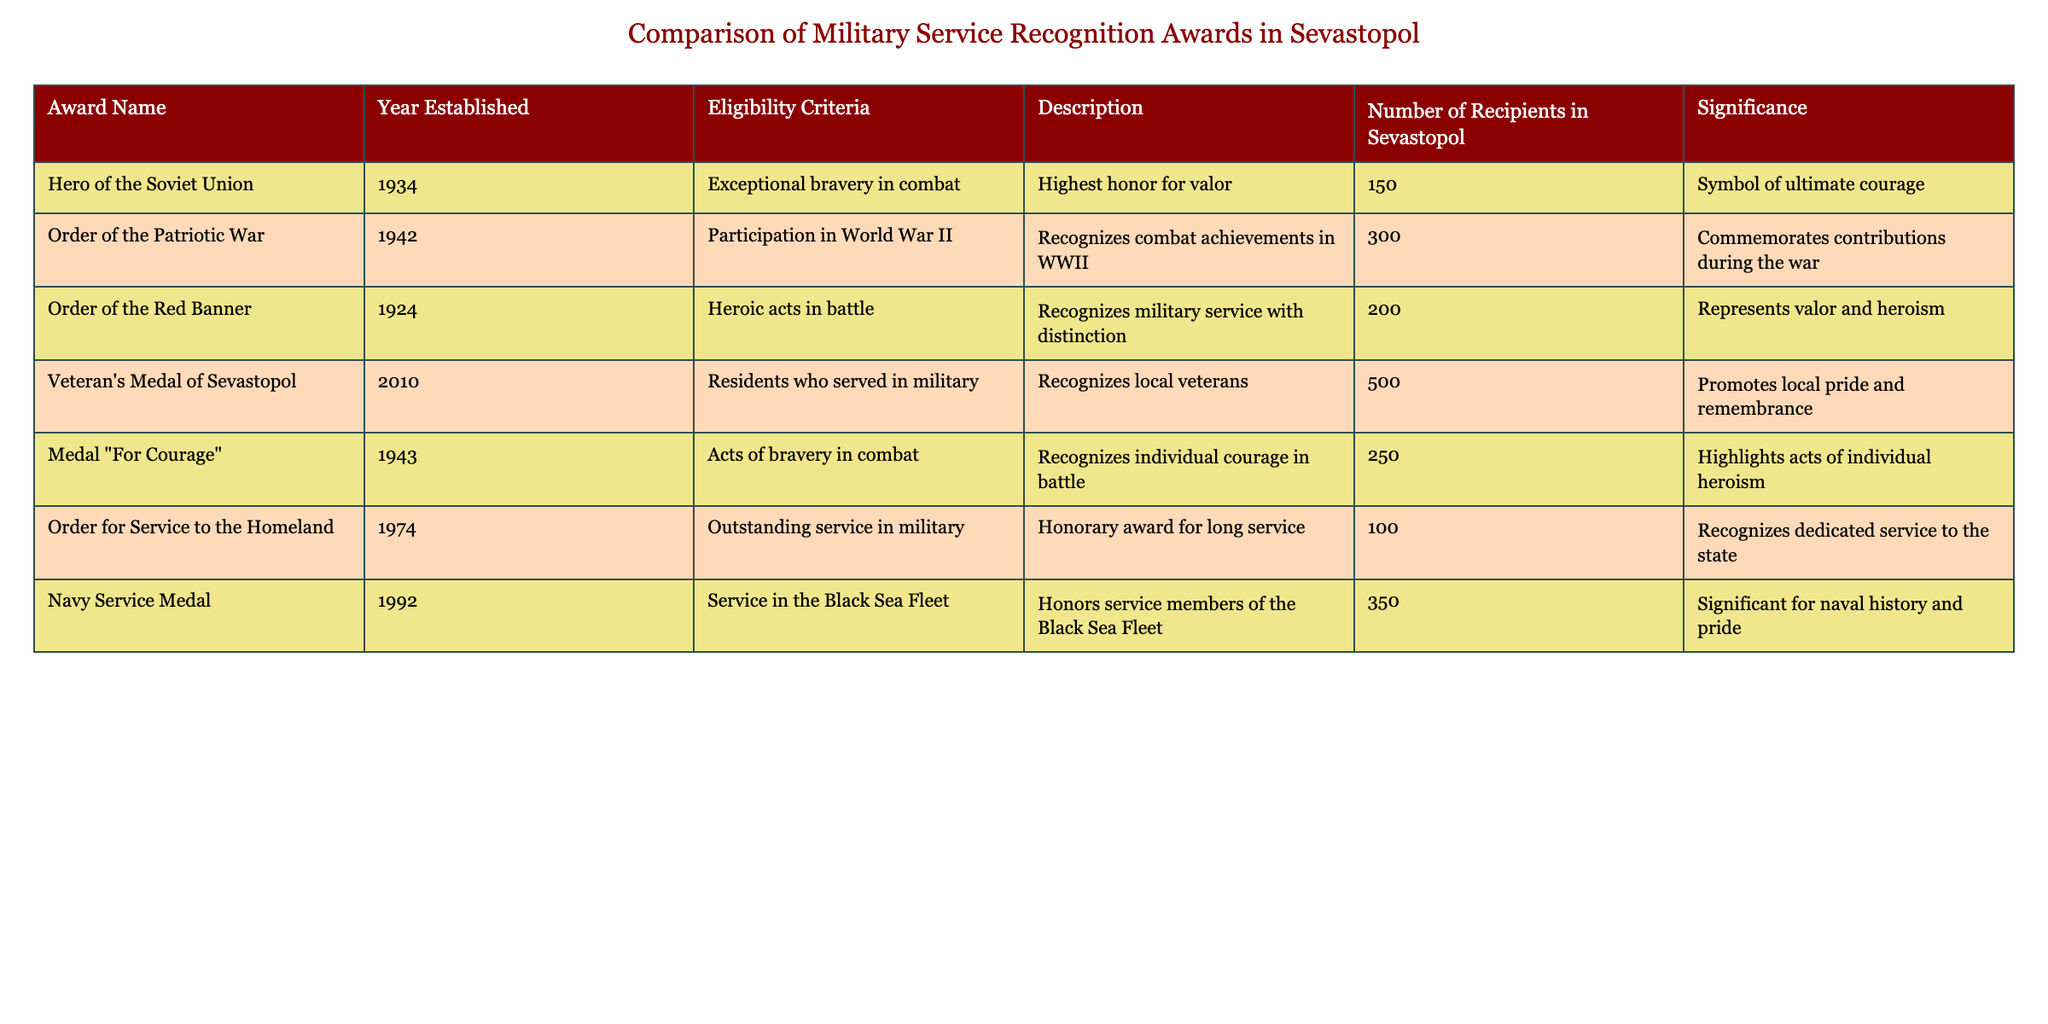What is the significance of the Hero of the Soviet Union award? The significance of the Hero of the Soviet Union award, as noted in the table, is that it symbolizes ultimate courage.
Answer: Symbol of ultimate courage How many total recipients are there for the Navy Service Medal and the Veteran's Medal of Sevastopol combined? To find the total recipients, sum the number of recipients for both awards: 350 (Navy Service Medal) + 500 (Veteran's Medal of Sevastopol) = 850.
Answer: 850 Is the Order of the Red Banner awarded for participation in World War II? According to the table, the Order of the Red Banner is awarded for heroic acts in battle but not specifically for participation in World War II, which is the criteria for the Order of the Patriotic War.
Answer: No Which award has the highest number of recipients among veterans in Sevastopol? By comparing the number of recipients listed in the table, the Veteran's Medal of Sevastopol has the highest number, with 500 recipients.
Answer: Veteran's Medal of Sevastopol What is the average number of recipients for the awards established before 1950? To find the average, first identify the awards established before 1950: Hero of the Soviet Union (150), Order of the Patriotic War (300), Order of the Red Banner (200), and Medal "For Courage" (250). The total is 150 + 300 + 200 + 250 = 900, and there are 4 awards. Therefore, the average is 900 / 4 = 225.
Answer: 225 Does the Medal "For Courage" recognize individual acts of bravery? The table specifies that the Medal "For Courage" is awarded for acts of bravery in combat, indicating that it does recognize individual acts of bravery.
Answer: Yes How many more recipients does the Order of the Patriotic War have compared to the Order for Service to the Homeland? The Order of the Patriotic War has 300 recipients, while the Order for Service to the Homeland has 100 recipients. The difference is 300 - 100 = 200.
Answer: 200 What is the year established for the Order of the Patriotic War? The table shows that the Order of the Patriotic War was established in 1942.
Answer: 1942 